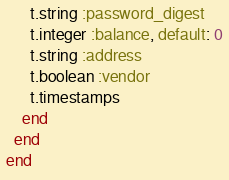<code> <loc_0><loc_0><loc_500><loc_500><_Ruby_>      t.string :password_digest
      t.integer :balance, default: 0
      t.string :address
      t.boolean :vendor
      t.timestamps
    end
  end
end
</code> 